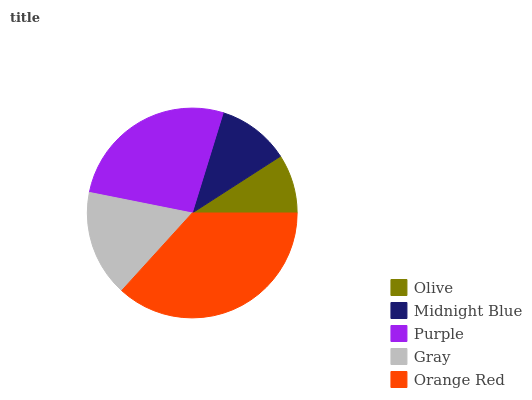Is Olive the minimum?
Answer yes or no. Yes. Is Orange Red the maximum?
Answer yes or no. Yes. Is Midnight Blue the minimum?
Answer yes or no. No. Is Midnight Blue the maximum?
Answer yes or no. No. Is Midnight Blue greater than Olive?
Answer yes or no. Yes. Is Olive less than Midnight Blue?
Answer yes or no. Yes. Is Olive greater than Midnight Blue?
Answer yes or no. No. Is Midnight Blue less than Olive?
Answer yes or no. No. Is Gray the high median?
Answer yes or no. Yes. Is Gray the low median?
Answer yes or no. Yes. Is Purple the high median?
Answer yes or no. No. Is Orange Red the low median?
Answer yes or no. No. 